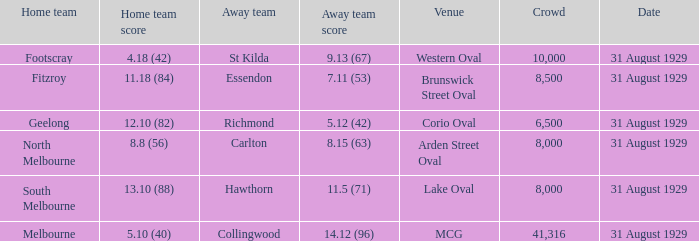What was the away team when the game was at corio oval? Richmond. 